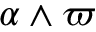Convert formula to latex. <formula><loc_0><loc_0><loc_500><loc_500>\alpha \wedge \varpi</formula> 